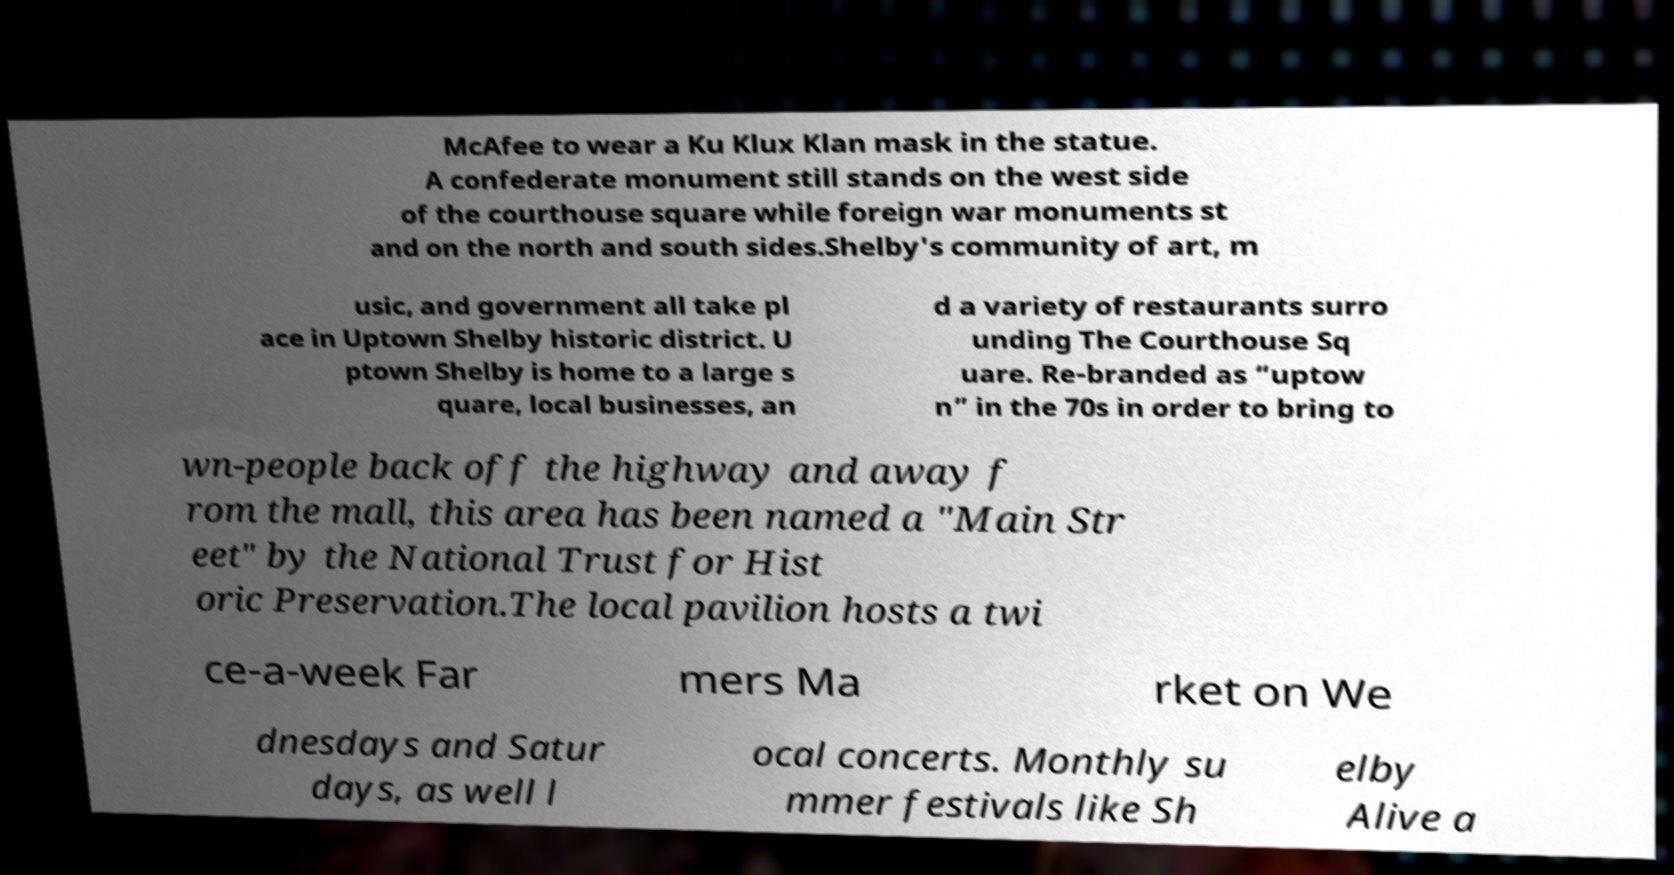Could you extract and type out the text from this image? McAfee to wear a Ku Klux Klan mask in the statue. A confederate monument still stands on the west side of the courthouse square while foreign war monuments st and on the north and south sides.Shelby's community of art, m usic, and government all take pl ace in Uptown Shelby historic district. U ptown Shelby is home to a large s quare, local businesses, an d a variety of restaurants surro unding The Courthouse Sq uare. Re-branded as “uptow n” in the 70s in order to bring to wn-people back off the highway and away f rom the mall, this area has been named a "Main Str eet" by the National Trust for Hist oric Preservation.The local pavilion hosts a twi ce-a-week Far mers Ma rket on We dnesdays and Satur days, as well l ocal concerts. Monthly su mmer festivals like Sh elby Alive a 